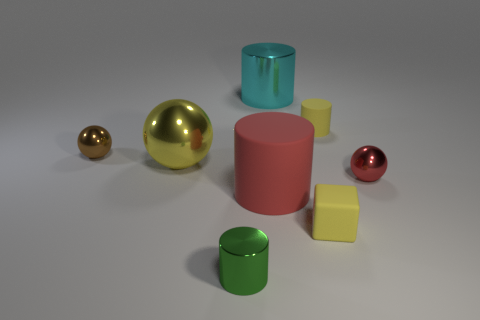Subtract all yellow metallic balls. How many balls are left? 2 Subtract all blocks. How many objects are left? 7 Subtract 1 blocks. How many blocks are left? 0 Add 3 large metal objects. How many large metal objects exist? 5 Add 1 small green cylinders. How many objects exist? 9 Subtract all yellow balls. How many balls are left? 2 Subtract 0 cyan spheres. How many objects are left? 8 Subtract all green blocks. Subtract all gray cylinders. How many blocks are left? 1 Subtract all blue blocks. How many green spheres are left? 0 Subtract all small shiny cylinders. Subtract all small blocks. How many objects are left? 6 